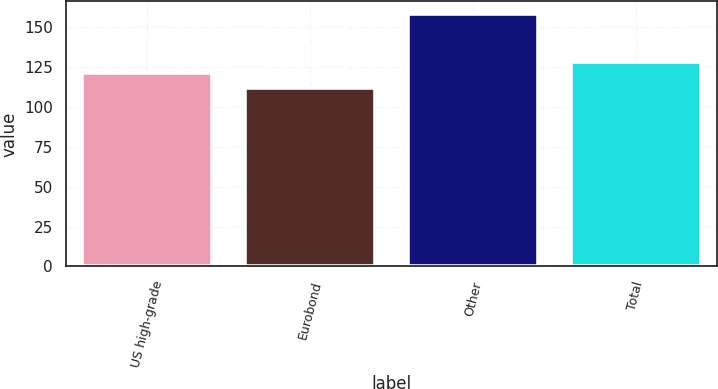Convert chart to OTSL. <chart><loc_0><loc_0><loc_500><loc_500><bar_chart><fcel>US high-grade<fcel>Eurobond<fcel>Other<fcel>Total<nl><fcel>121<fcel>112<fcel>158<fcel>128<nl></chart> 